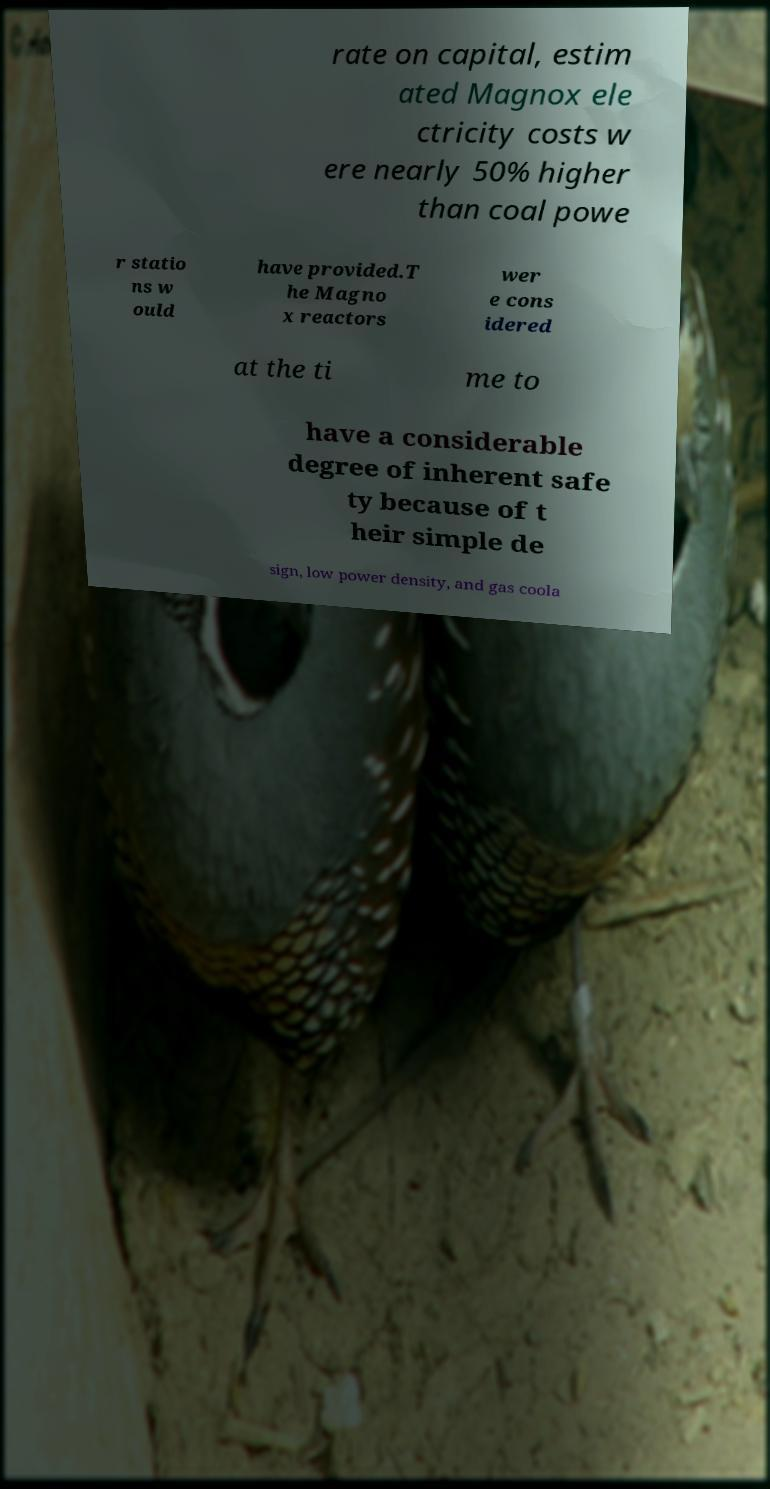I need the written content from this picture converted into text. Can you do that? rate on capital, estim ated Magnox ele ctricity costs w ere nearly 50% higher than coal powe r statio ns w ould have provided.T he Magno x reactors wer e cons idered at the ti me to have a considerable degree of inherent safe ty because of t heir simple de sign, low power density, and gas coola 